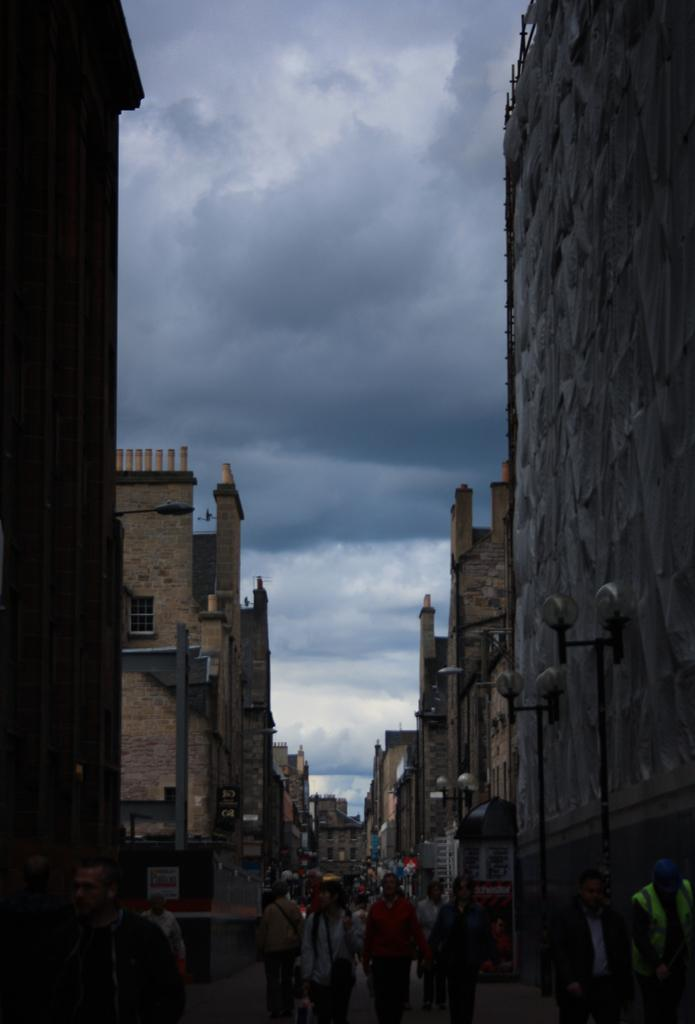What are the people in the image doing? The people in the image are walking on a path in the foreground. What can be seen on either side of the path? There are buildings on either side of the path. What is visible at the top of the image? The sky is visible at the top of the image. Where is the store located in the image? There is no store mentioned or visible in the image. What color is the orange on the path? There is no orange present in the image. 